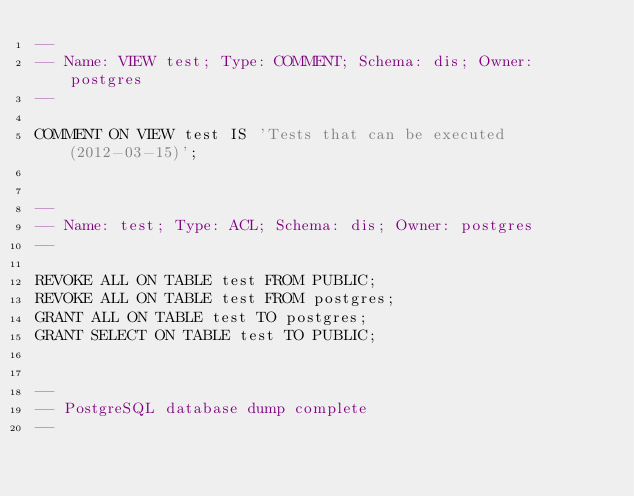<code> <loc_0><loc_0><loc_500><loc_500><_SQL_>--
-- Name: VIEW test; Type: COMMENT; Schema: dis; Owner: postgres
--

COMMENT ON VIEW test IS 'Tests that can be executed (2012-03-15)';


--
-- Name: test; Type: ACL; Schema: dis; Owner: postgres
--

REVOKE ALL ON TABLE test FROM PUBLIC;
REVOKE ALL ON TABLE test FROM postgres;
GRANT ALL ON TABLE test TO postgres;
GRANT SELECT ON TABLE test TO PUBLIC;


--
-- PostgreSQL database dump complete
--

</code> 